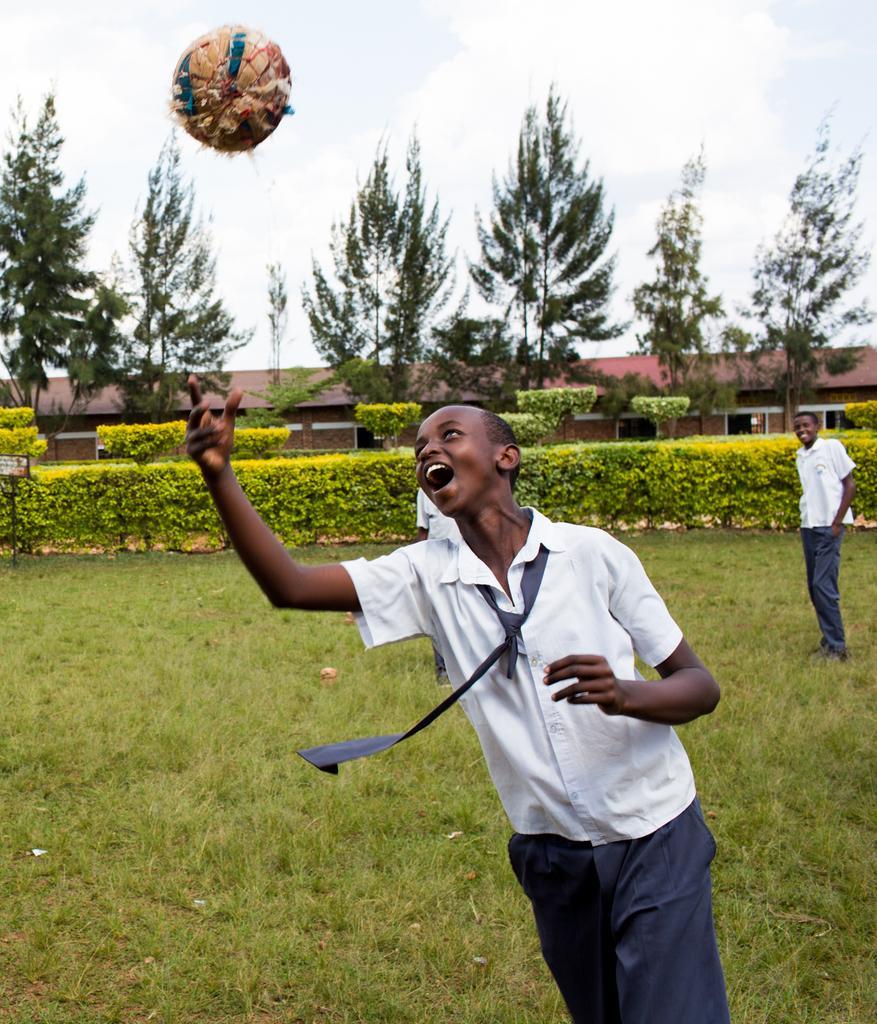Can you describe this image briefly? In the middle there is a boy, he wears a shirt, trouser, tie, he is throwing a ball. At the bottom there are plants and grass. In the middle there are trees, person, house, sky and clouds. 